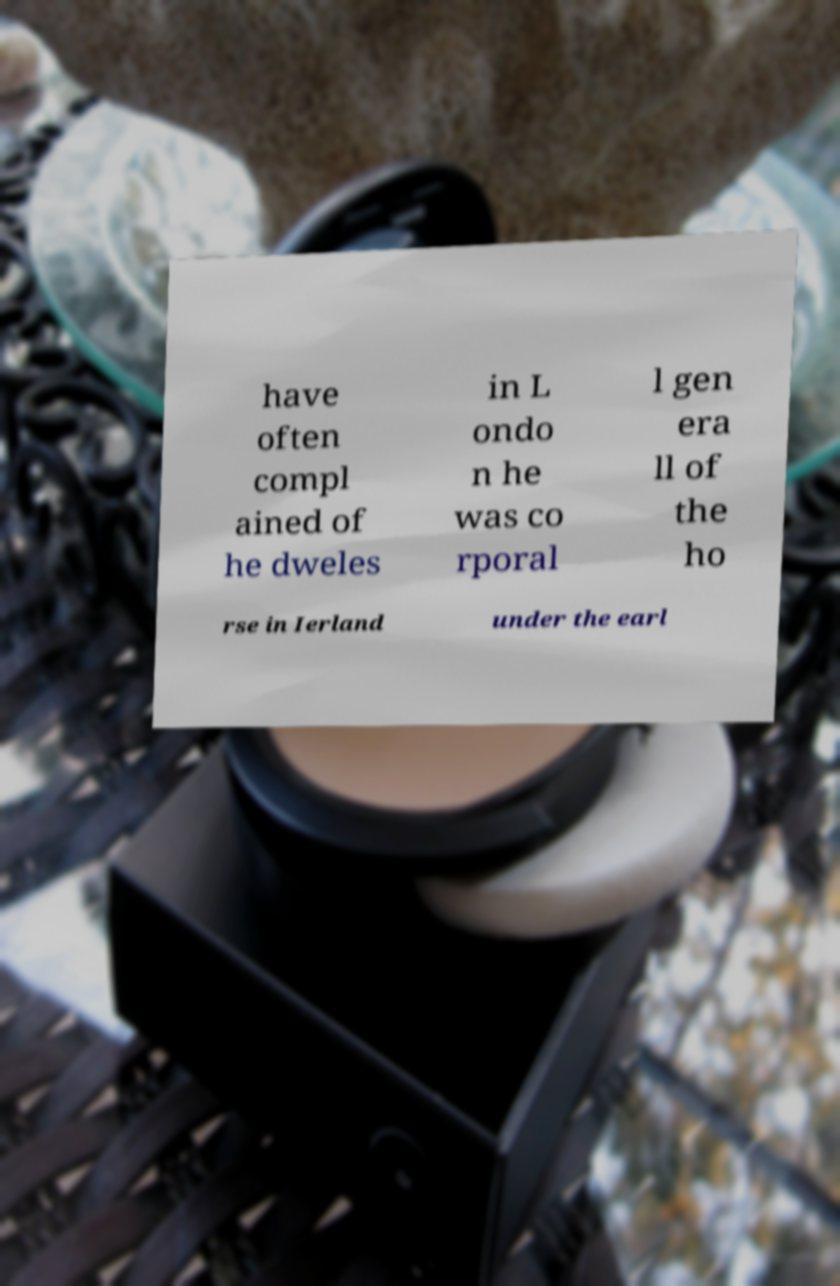I need the written content from this picture converted into text. Can you do that? have often compl ained of he dweles in L ondo n he was co rporal l gen era ll of the ho rse in Ierland under the earl 